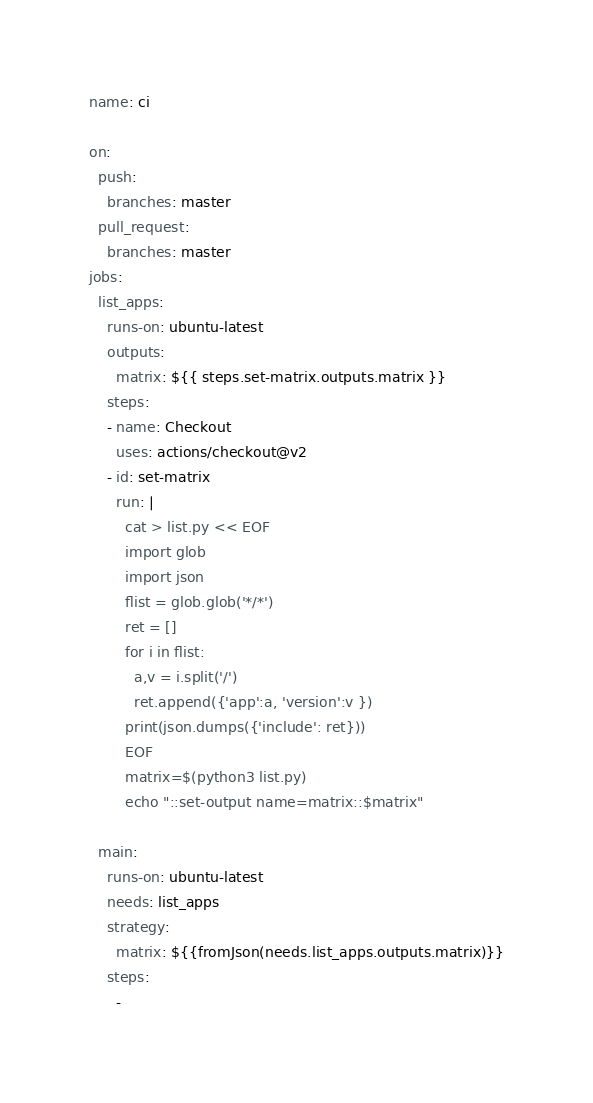Convert code to text. <code><loc_0><loc_0><loc_500><loc_500><_YAML_>name: ci

on:
  push:
    branches: master
  pull_request:
    branches: master
jobs:
  list_apps:
    runs-on: ubuntu-latest
    outputs:
      matrix: ${{ steps.set-matrix.outputs.matrix }}
    steps:
    - name: Checkout
      uses: actions/checkout@v2
    - id: set-matrix
      run: |
        cat > list.py << EOF
        import glob
        import json
        flist = glob.glob('*/*')
        ret = []
        for i in flist:
          a,v = i.split('/')
          ret.append({'app':a, 'version':v })
        print(json.dumps({'include': ret}))
        EOF
        matrix=$(python3 list.py)
        echo "::set-output name=matrix::$matrix"

  main:
    runs-on: ubuntu-latest
    needs: list_apps
    strategy:
      matrix: ${{fromJson(needs.list_apps.outputs.matrix)}}
    steps:
      -</code> 